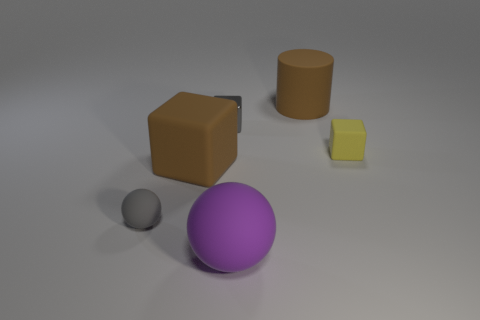Are there more rubber things left of the matte cylinder than gray objects in front of the purple matte thing?
Make the answer very short. Yes. What size is the yellow thing?
Keep it short and to the point. Small. There is a big rubber thing that is in front of the gray rubber object; what shape is it?
Your answer should be very brief. Sphere. Is the gray rubber thing the same shape as the small yellow rubber object?
Your answer should be very brief. No. Are there the same number of yellow rubber objects that are left of the gray metallic thing and small blue metal cylinders?
Offer a very short reply. Yes. What is the shape of the yellow matte thing?
Keep it short and to the point. Cube. Is there any other thing that has the same color as the large rubber ball?
Ensure brevity in your answer.  No. Is the size of the rubber thing on the left side of the big rubber cube the same as the cube that is behind the tiny matte block?
Provide a succinct answer. Yes. There is a brown matte object behind the tiny gray thing behind the tiny ball; what is its shape?
Offer a terse response. Cylinder. Is the size of the gray shiny thing the same as the gray ball left of the large brown cylinder?
Ensure brevity in your answer.  Yes. 